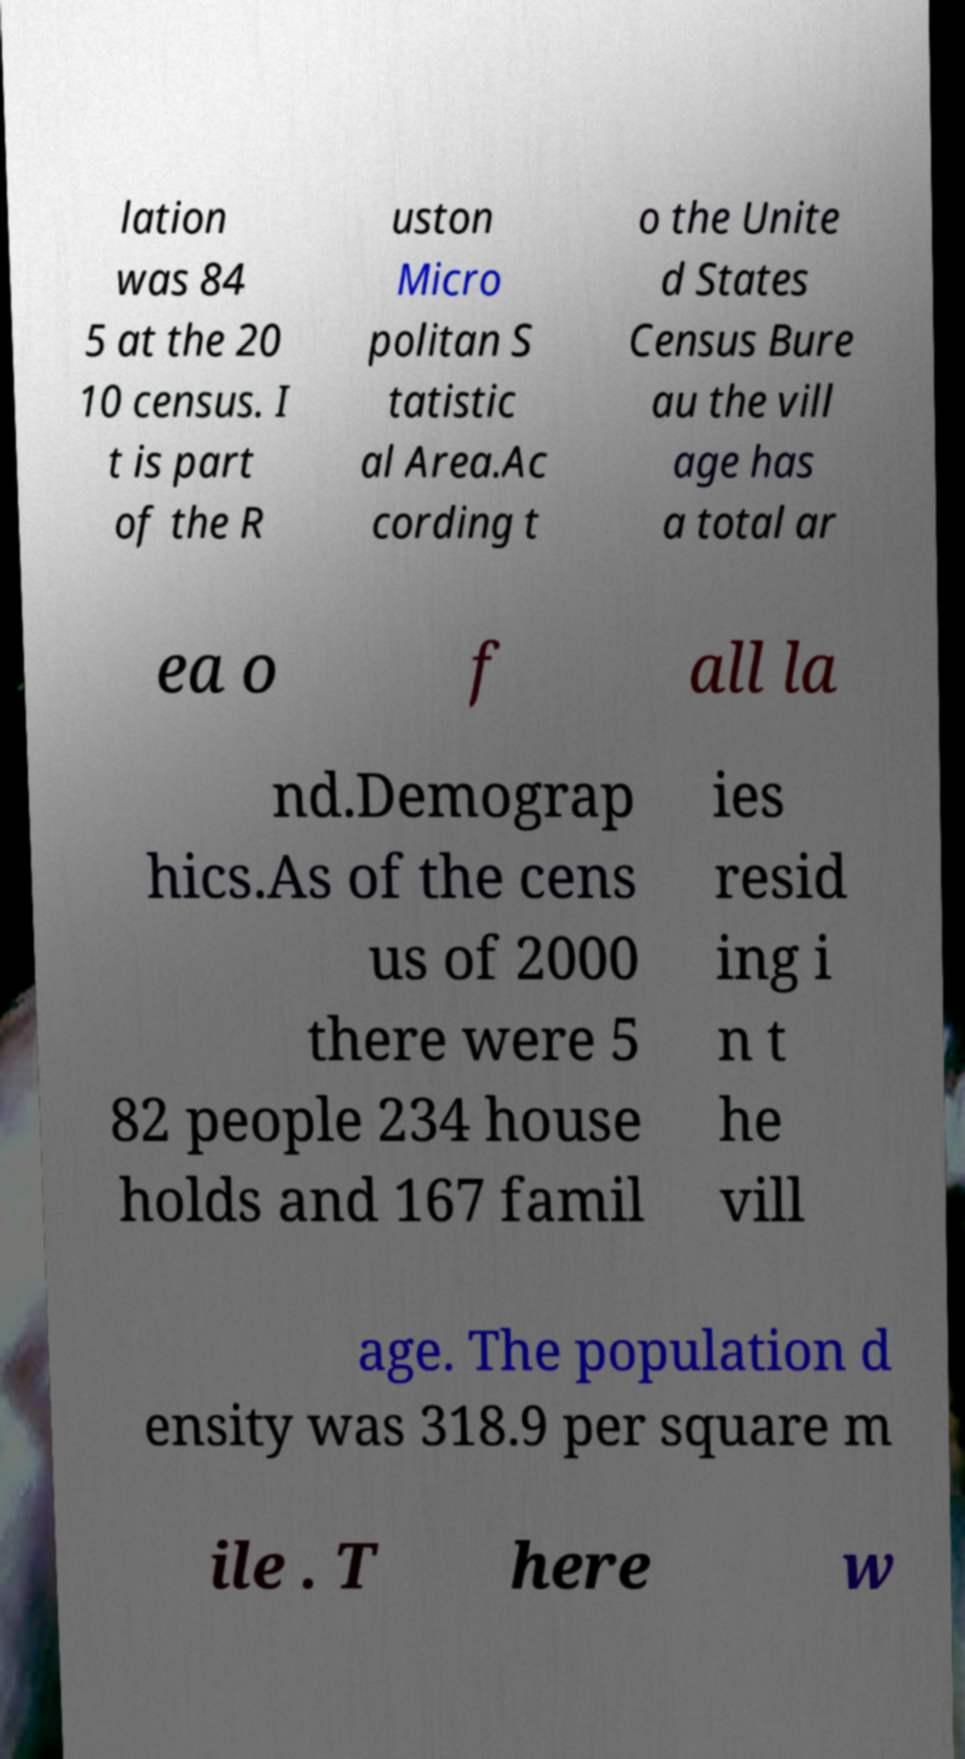There's text embedded in this image that I need extracted. Can you transcribe it verbatim? lation was 84 5 at the 20 10 census. I t is part of the R uston Micro politan S tatistic al Area.Ac cording t o the Unite d States Census Bure au the vill age has a total ar ea o f all la nd.Demograp hics.As of the cens us of 2000 there were 5 82 people 234 house holds and 167 famil ies resid ing i n t he vill age. The population d ensity was 318.9 per square m ile . T here w 